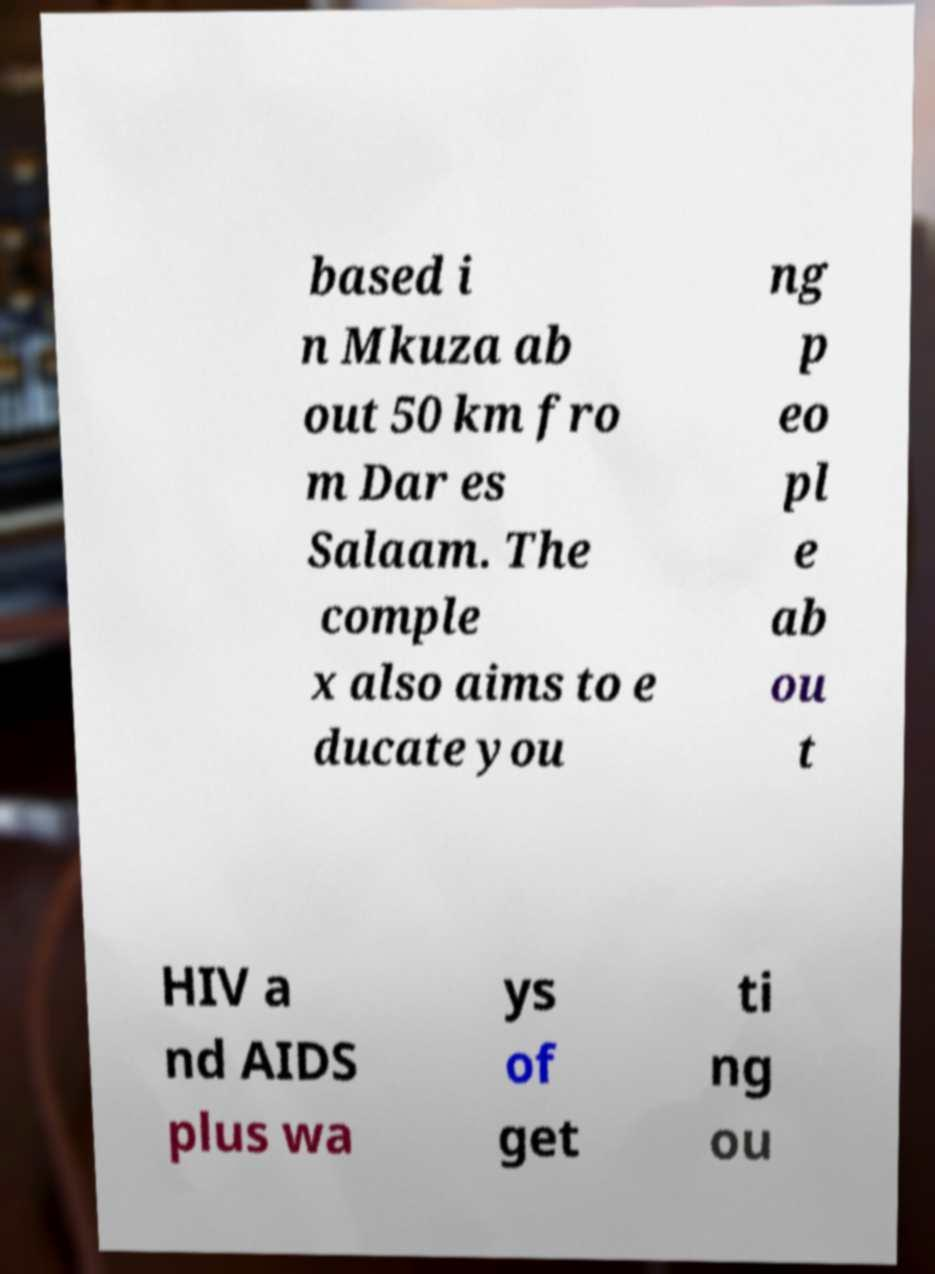Could you assist in decoding the text presented in this image and type it out clearly? based i n Mkuza ab out 50 km fro m Dar es Salaam. The comple x also aims to e ducate you ng p eo pl e ab ou t HIV a nd AIDS plus wa ys of get ti ng ou 